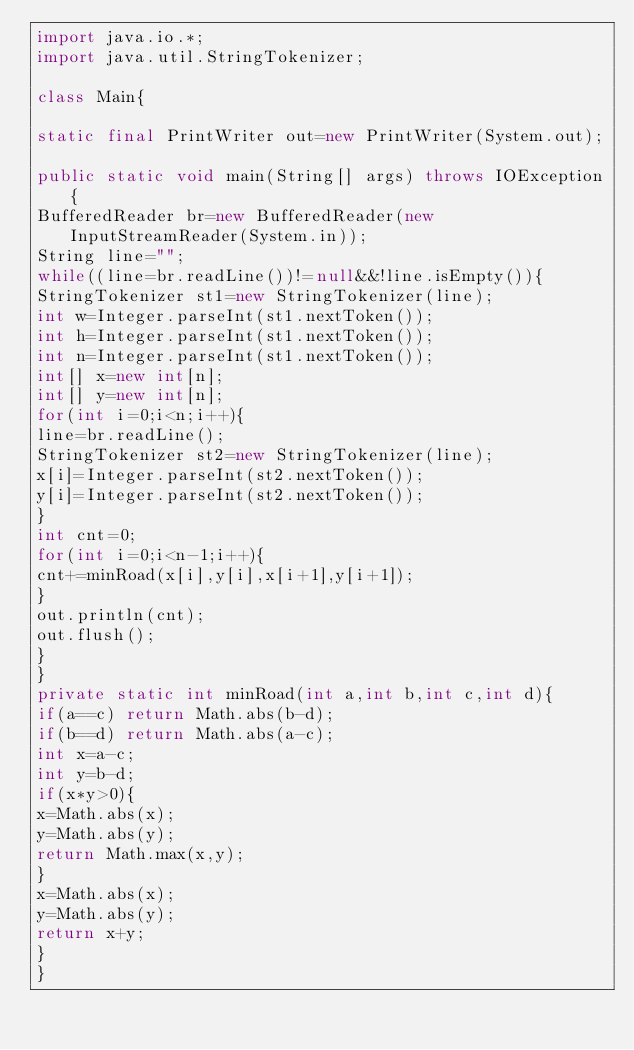Convert code to text. <code><loc_0><loc_0><loc_500><loc_500><_Java_>import java.io.*;
import java.util.StringTokenizer;

class Main{

static final PrintWriter out=new PrintWriter(System.out);

public static void main(String[] args) throws IOException{
BufferedReader br=new BufferedReader(new InputStreamReader(System.in));
String line="";
while((line=br.readLine())!=null&&!line.isEmpty()){
StringTokenizer st1=new StringTokenizer(line);
int w=Integer.parseInt(st1.nextToken());
int h=Integer.parseInt(st1.nextToken());
int n=Integer.parseInt(st1.nextToken());
int[] x=new int[n];
int[] y=new int[n];
for(int i=0;i<n;i++){
line=br.readLine();
StringTokenizer st2=new StringTokenizer(line);
x[i]=Integer.parseInt(st2.nextToken());
y[i]=Integer.parseInt(st2.nextToken());
}
int cnt=0;
for(int i=0;i<n-1;i++){
cnt+=minRoad(x[i],y[i],x[i+1],y[i+1]);
}
out.println(cnt);
out.flush();
}
}
private static int minRoad(int a,int b,int c,int d){
if(a==c) return Math.abs(b-d);
if(b==d) return Math.abs(a-c);
int x=a-c;
int y=b-d;
if(x*y>0){
x=Math.abs(x);
y=Math.abs(y);
return Math.max(x,y);
}
x=Math.abs(x);
y=Math.abs(y);
return x+y;
}
}</code> 